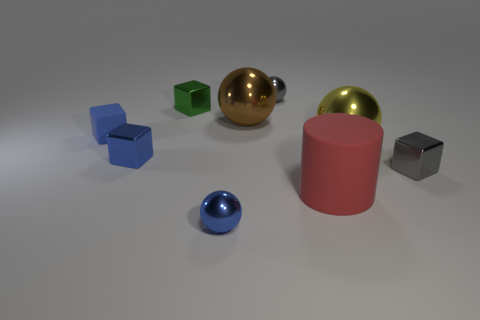Subtract 1 cubes. How many cubes are left? 3 Add 1 rubber things. How many objects exist? 10 Subtract all balls. How many objects are left? 5 Subtract 0 cyan cylinders. How many objects are left? 9 Subtract all large rubber cylinders. Subtract all small blue metallic balls. How many objects are left? 7 Add 5 gray metal balls. How many gray metal balls are left? 6 Add 7 rubber cubes. How many rubber cubes exist? 8 